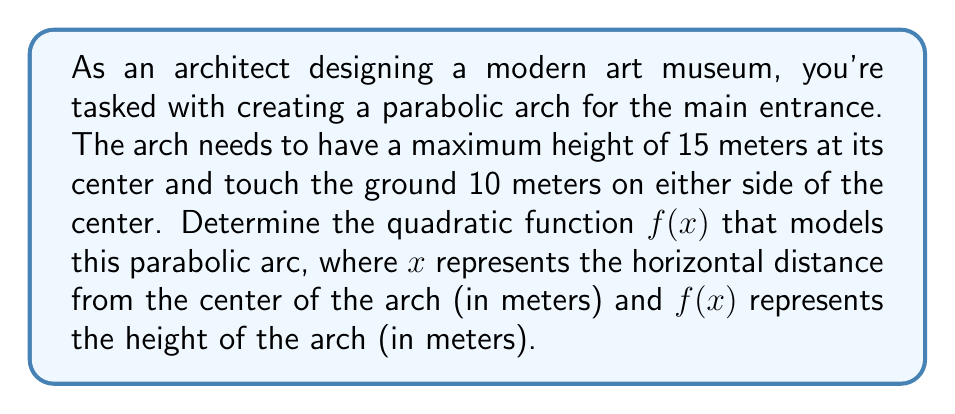Give your solution to this math problem. Let's approach this step-by-step:

1) The general form of a quadratic function is $f(x) = ax^2 + bx + c$, where $a$, $b$, and $c$ are constants and $a \neq 0$.

2) We know three key points about this parabola:
   - At the center (0, 15): $f(0) = 15$
   - At the left base (-10, 0): $f(-10) = 0$
   - At the right base (10, 0): $f(10) = 0$

3) Since the parabola is symmetrical and centered at $x = 0$, we know that $b = 0$. Our function simplifies to $f(x) = ax^2 + c$.

4) Using the center point (0, 15):
   $15 = a(0)^2 + c$
   $c = 15$

5) Now our function is $f(x) = ax^2 + 15$

6) Using either base point, let's use (10, 0):
   $0 = a(10)^2 + 15$
   $-15 = 100a$
   $a = -\frac{15}{100} = -0.15$

7) Therefore, our quadratic function is:
   $f(x) = -0.15x^2 + 15$

We can verify this with the other base point (-10, 0):
$f(-10) = -0.15(-10)^2 + 15 = -0.15(100) + 15 = -15 + 15 = 0$

[asy]
import graph;
size(200,200);
real f(real x) {return -0.15*x^2 + 15;}
xaxis("x",-12,12,arrow=Arrow);
yaxis("y",0,18,arrow=Arrow);
draw(graph(f,-10,10),blue);
dot((0,15));
dot((-10,0));
dot((10,0));
label("(0,15)",(0,15),N);
label("(-10,0)",(-10,0),SW);
label("(10,0)",(10,0),SE);
[/asy]
Answer: The quadratic function modeling the parabolic arc is $f(x) = -0.15x^2 + 15$, where $x$ is the horizontal distance from the center in meters and $f(x)$ is the height in meters. 